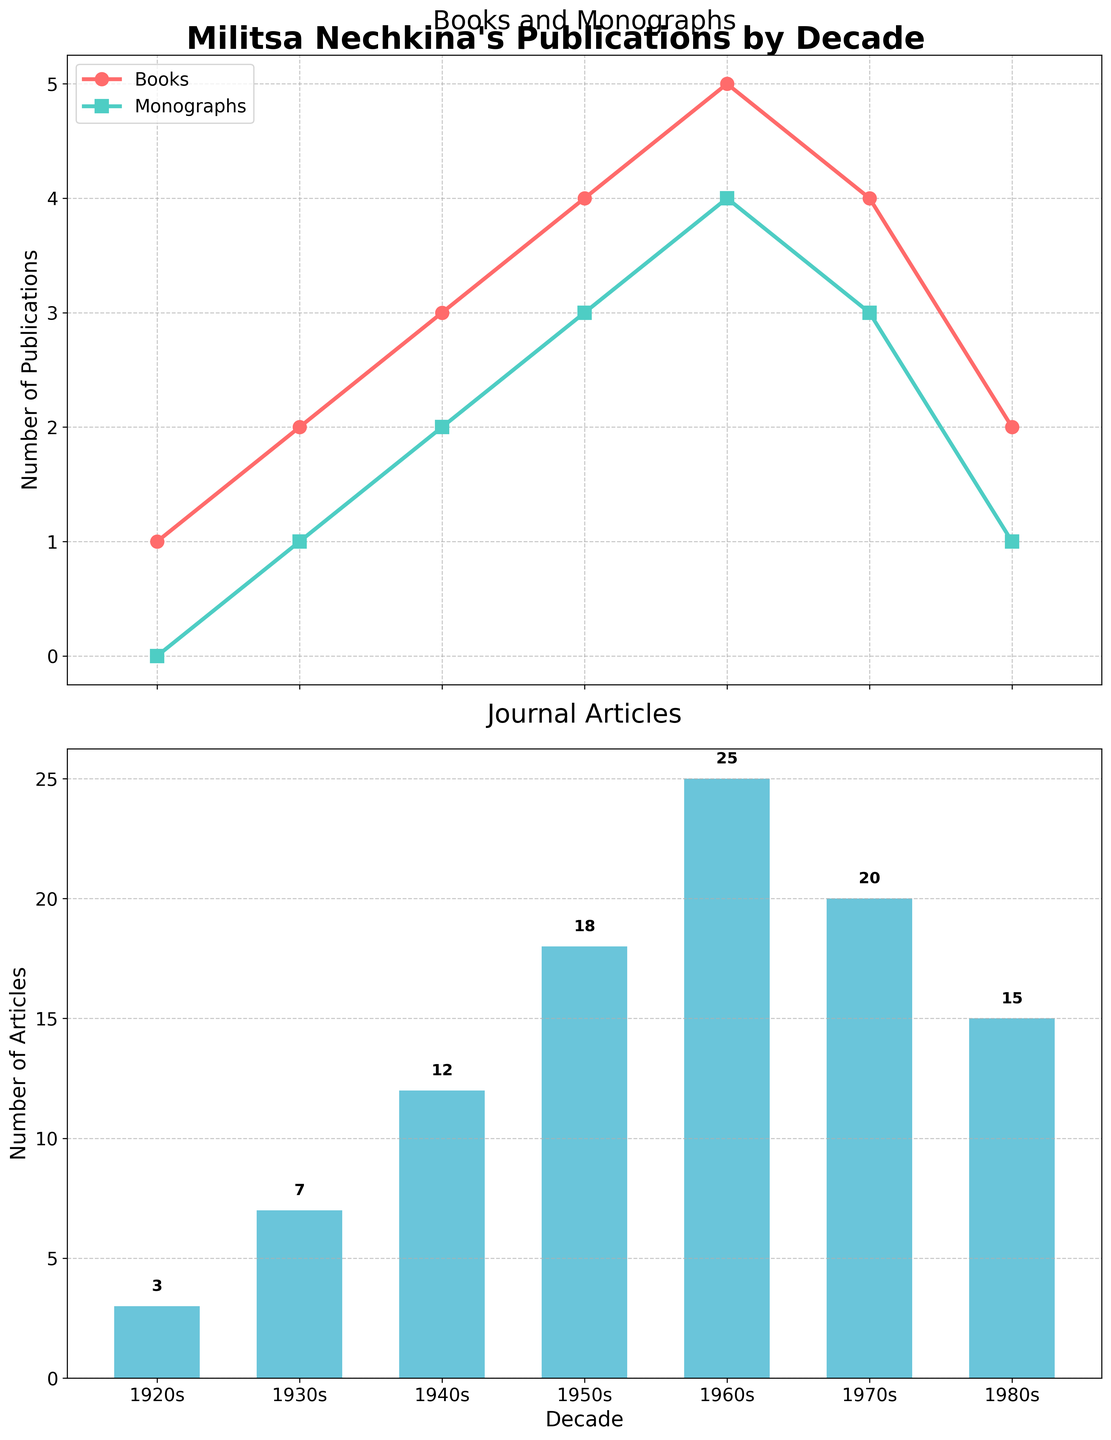How many total publications did Militsa Nechkina have in the 1950s? To find the total number of publications in the 1950s, add the number of books, monographs, and journal articles for that decade: 4 (Books) + 3 (Monographs) + 18 (Journal Articles) = 25
Answer: 25 In which decade did Militsa Nechkina publish the most journal articles? Review the bars in the lower subplot and identify the highest one, which corresponds to the 1960s with 25 journal articles
Answer: 1960s How many more books did she publish in the 1960s compared to the 1980s? Subtract the number of books in the 1980s (2) from the number in the 1960s (5): 5 - 2 = 3
Answer: 3 Are there any decades where Militsa Nechkina published equal numbers of books and monographs? Compare the data points for books and monographs across all decades. In the 1970s, she published 4 books and 4 monographs
Answer: 1970s What is the total number of monographs published over all decades? Sum the number of monographs across all decades: 0 (1920s) + 1 (1930s) + 2 (1940s) + 3 (1950s) + 4 (1960s) + 3 (1970s) + 1 (1980s) = 14
Answer: 14 How did the number of journal articles change from the 1920s to the 1930s? Subtract the number of articles in the 1920s (3) from the number in the 1930s (7): 7 - 3 = 4
Answer: increased by 4 Which type of publication saw a peak in the 1960s? Identify which line or bar reaches its maximum in the 1960s. Books, monographs, and journal articles all peak in this decade
Answer: Books, Monographs, Journal Articles What was the combined total of books and monographs published in the 1940s? Add the number of books and monographs in the 1940s: 3 (Books) + 2 (Monographs) = 5
Answer: 5 How many decades show a decrease in the number of journal articles compared to the previous decade? Identify decades where the bar height decreases from the previous decade. The 1970s (down from 1960s) and the 1980s (down from 1970s) show decreases
Answer: 2 decades In which decade was there the smallest number of total publications, and what is the number? Calculate the sum of books, monographs, and journal articles for each decade. The 1920s have the smallest total with 1 (Books) + 0 (Monographs) + 3 (Journal Articles) = 4
Answer: 1920s, 4 